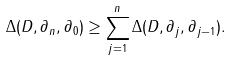<formula> <loc_0><loc_0><loc_500><loc_500>\Delta ( D , \partial _ { n } , \partial _ { 0 } ) \geq \sum _ { j = 1 } ^ { n } \Delta ( D , \partial _ { j } , \partial _ { j - 1 } ) .</formula> 